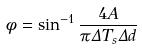Convert formula to latex. <formula><loc_0><loc_0><loc_500><loc_500>\phi = \sin ^ { - 1 } \frac { 4 A } { \pi \Delta T _ { s } \Delta d }</formula> 